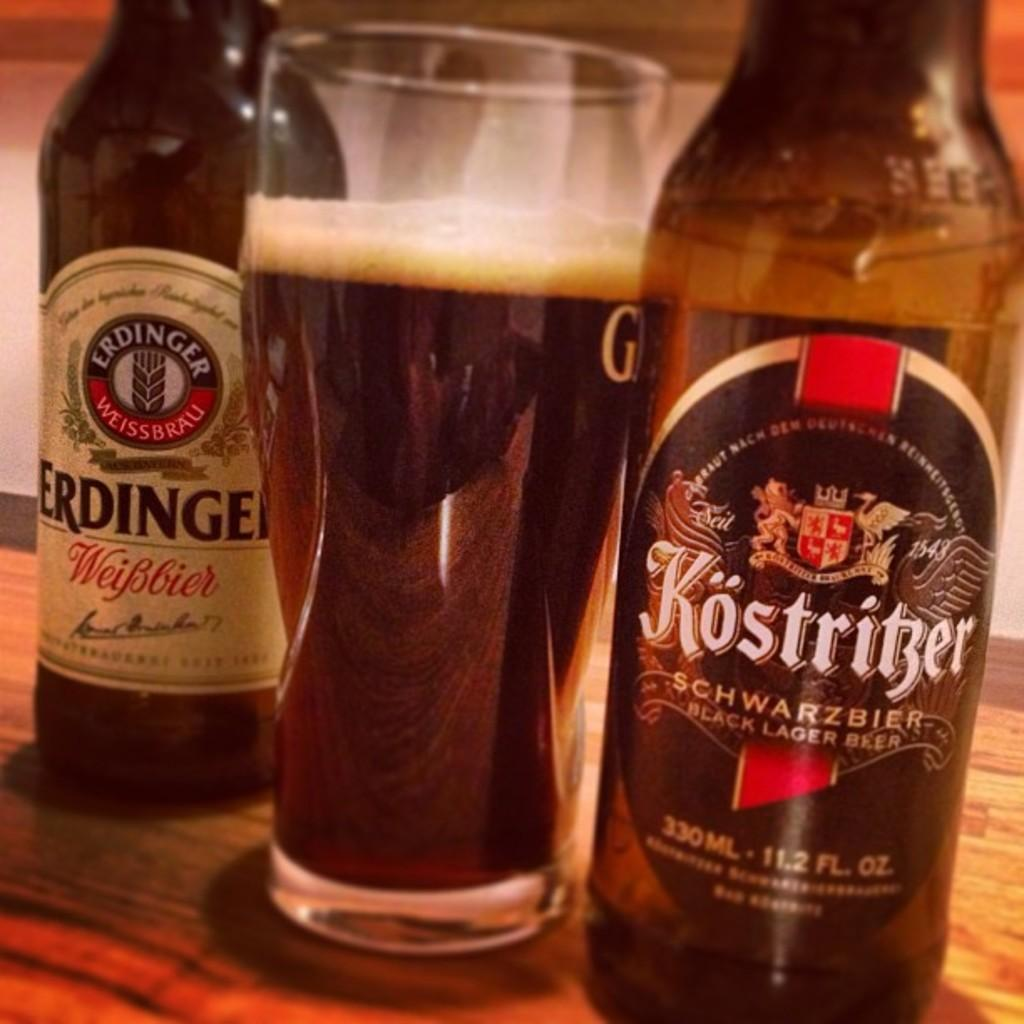<image>
Relay a brief, clear account of the picture shown. Bottle of Kostriber beer next to a cup of beer. 